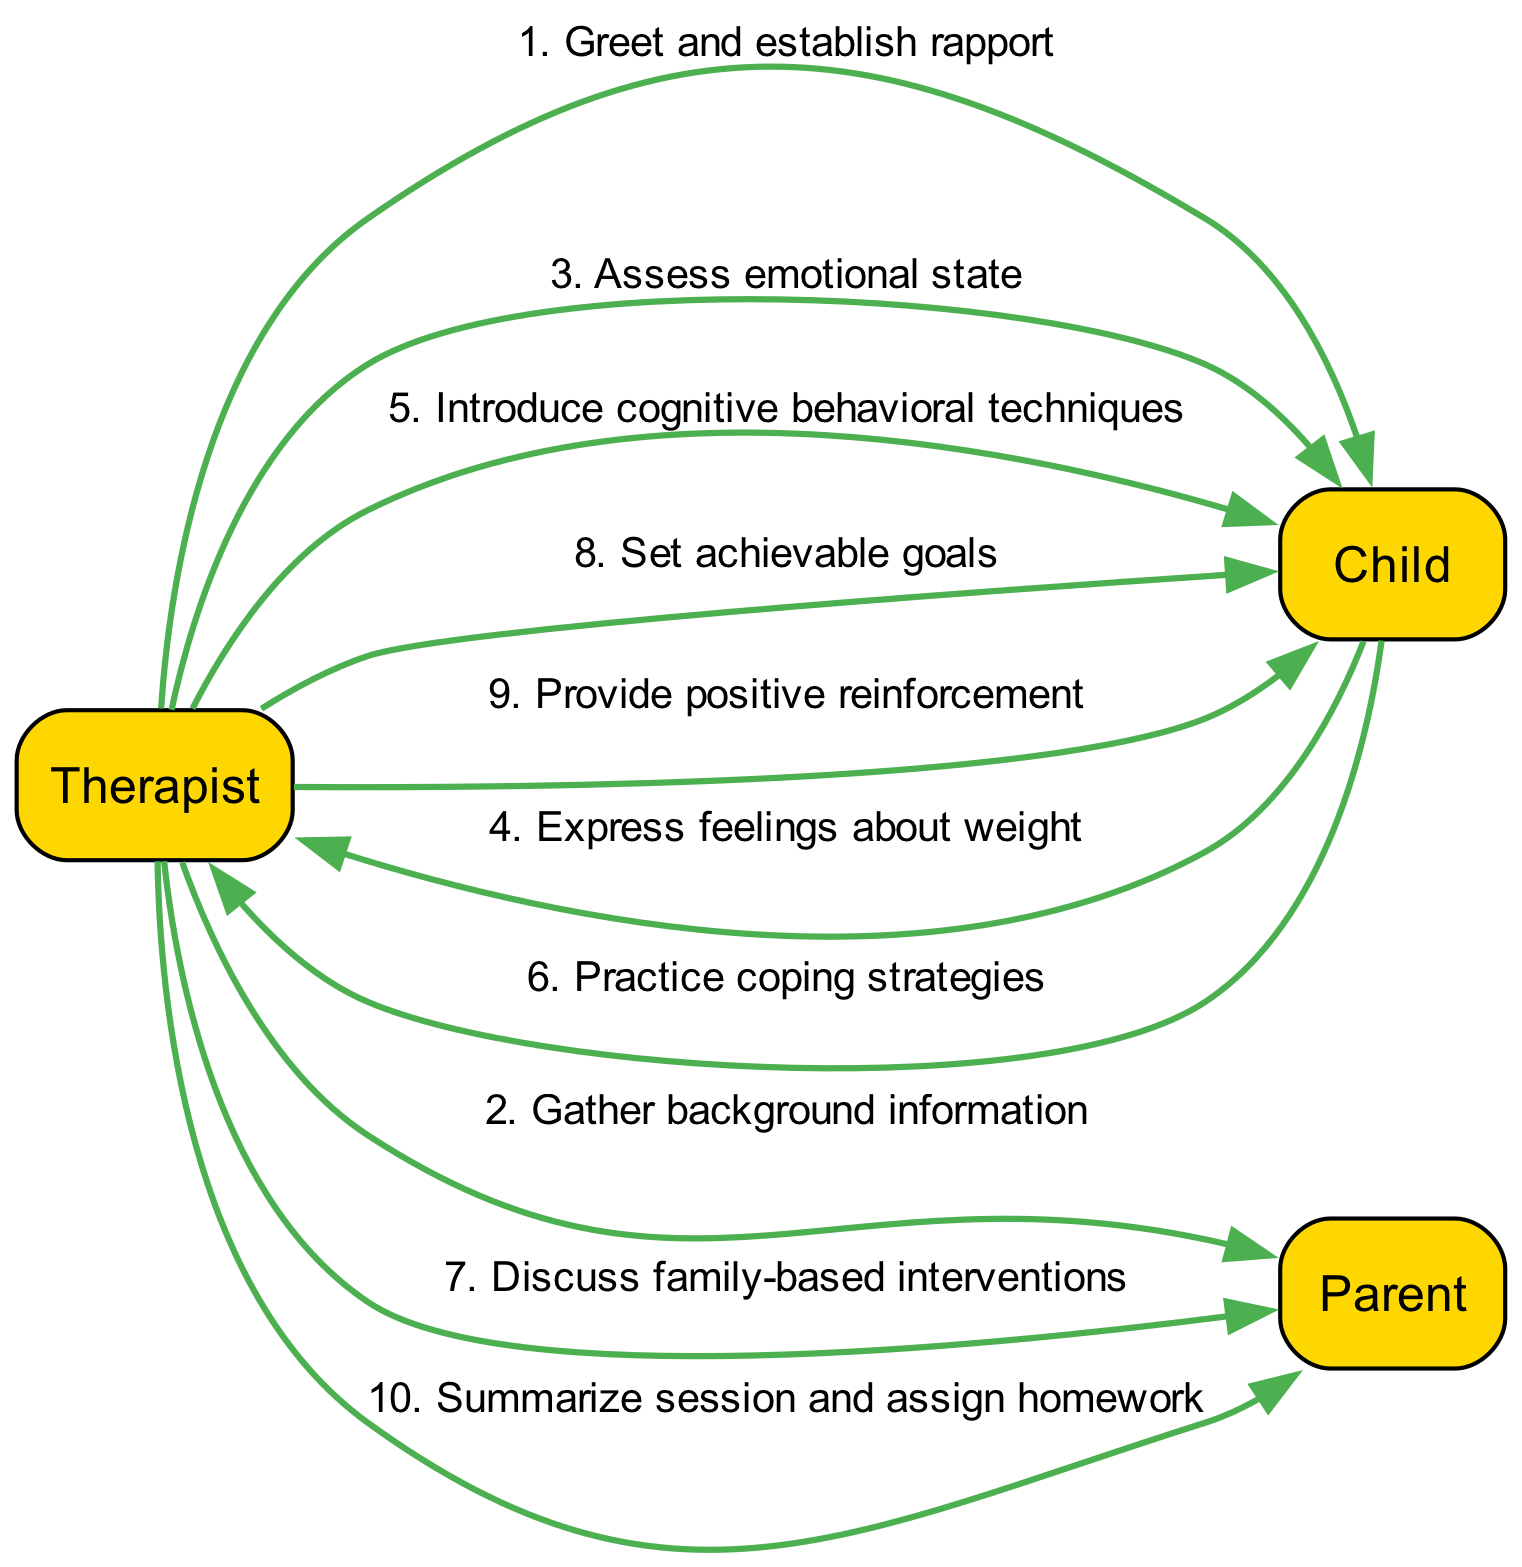What is the first action in the sequence? The first action listed in the sequence is "Greet and establish rapport," which shows the therapist starting the session with the child.
Answer: Greet and establish rapport How many actions are directed from the therapist to the child? By reviewing the sequence, I can count that there are five actions directed from the therapist to the child in total: greeting, assessing emotional state, introducing techniques, setting goals, and providing reinforcement.
Answer: Five What is the action taken by the child after expressing feelings about their weight? The action taken by the child after expressing their feelings is practicing coping strategies, showing engagement and willingness to work on issues related to their feelings about weight.
Answer: Practice coping strategies How many interactions involve the parent? To determine this, I look at the sequence and count the actions directed towards the parent, which includes three instances: gathering background information, discussing family-based interventions, and summarizing the session.
Answer: Three What is the last action in the sequence? The last action, which concludes the sequence of events, is "Summarize session and assign homework," indicating the end of the current therapy session and preparation for follow-up activities.
Answer: Summarize session and assign homework Which actor is involved in the most actions based on the sequence? By analyzing the events, the therapist is involved in a total of seven actions, while the child and the parent are involved in fewer actions, making the therapist the most active participant in the session.
Answer: Therapist What is the purpose of the action "Introduce cognitive behavioral techniques"? This action is aimed at providing the child with methods to change the way they think about their weight and behaviors, which is part of cognitive behavioral therapy aimed at addressing obesity-related issues.
Answer: Introduce cognitive behavioral techniques Which action immediately follows the "Assess emotional state"? The action that follows "Assess emotional state" is when the child expresses their feelings about weight, indicating that the assessment leads to the child sharing their emotions.
Answer: Express feelings about weight What is the primary focus of the session as perceived from the sequence of events? The primary focus revolves around improving the child's emotional well-being and developing practical strategies to address obesity-related behavioral issues.
Answer: Emotional well-being and strategies 